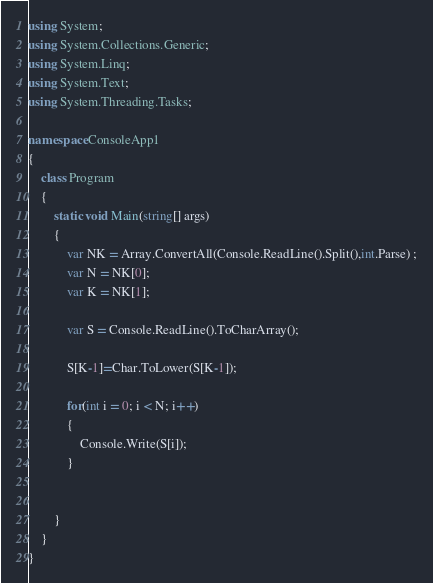Convert code to text. <code><loc_0><loc_0><loc_500><loc_500><_C#_>using System;
using System.Collections.Generic;
using System.Linq;
using System.Text;
using System.Threading.Tasks;

namespace ConsoleApp1
{
    class Program
    {
        static void Main(string[] args)
        {
            var NK = Array.ConvertAll(Console.ReadLine().Split(),int.Parse) ;
            var N = NK[0];
            var K = NK[1];

            var S = Console.ReadLine().ToCharArray();

            S[K-1]=Char.ToLower(S[K-1]);

            for(int i = 0; i < N; i++)
            {
                Console.Write(S[i]);
            }


        }
    }
}
</code> 